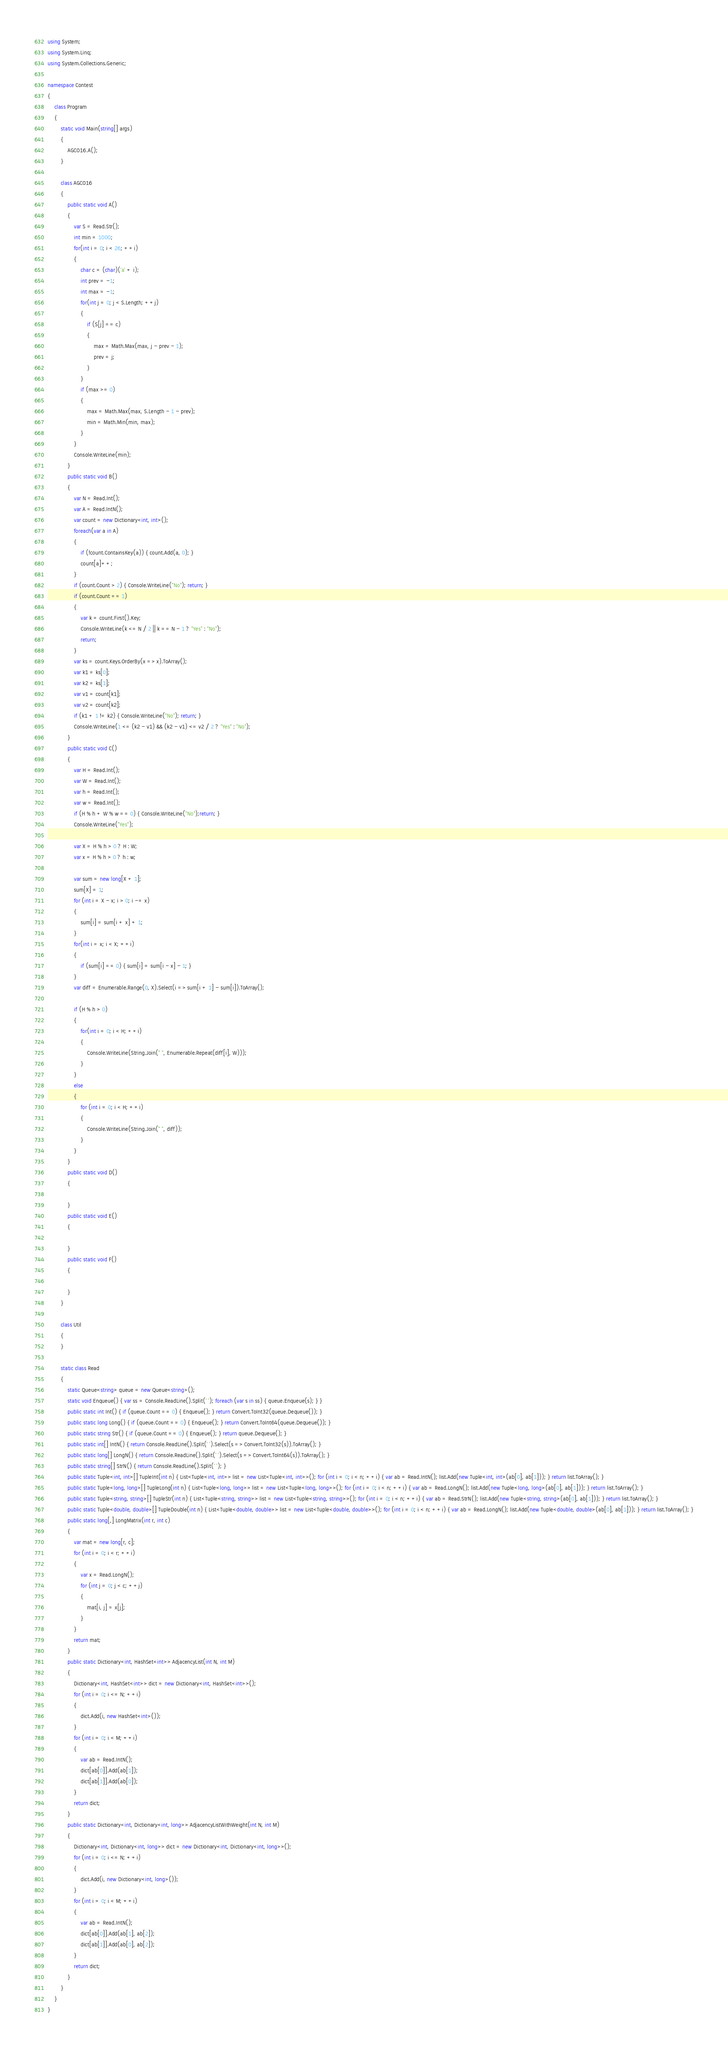Convert code to text. <code><loc_0><loc_0><loc_500><loc_500><_C#_>using System;
using System.Linq;
using System.Collections.Generic;

namespace Contest
{
    class Program
    {
        static void Main(string[] args)
        {
            AGC016.A();
        }

        class AGC016
        {
            public static void A()
            {
                var S = Read.Str();
                int min = 1000;
                for(int i = 0; i < 26; ++i)
                {
                    char c = (char)('a' + i);
                    int prev = -1;
                    int max = -1;
                    for(int j = 0; j < S.Length; ++j)
                    {
                        if (S[j] == c)
                        {
                            max = Math.Max(max, j - prev - 1);
                            prev = j;
                        }
                    }
                    if (max >= 0)
                    {
                        max = Math.Max(max, S.Length - 1 - prev);
                        min = Math.Min(min, max);
                    }
                }
                Console.WriteLine(min);
            }
            public static void B()
            {
                var N = Read.Int();
                var A = Read.IntN();
                var count = new Dictionary<int, int>();
                foreach(var a in A)
                {
                    if (!count.ContainsKey(a)) { count.Add(a, 0); }
                    count[a]++;
                }
                if (count.Count > 2) { Console.WriteLine("No"); return; }
                if (count.Count == 1)
                {
                    var k = count.First().Key;
                    Console.WriteLine(k <= N / 2 || k == N - 1 ? "Yes" : "No");
                    return;
                }
                var ks = count.Keys.OrderBy(x => x).ToArray();
                var k1 = ks[0];
                var k2 = ks[1];
                var v1 = count[k1];
                var v2 = count[k2];
                if (k1 + 1 != k2) { Console.WriteLine("No"); return; }
                Console.WriteLine(1 <= (k2 - v1) && (k2 - v1) <= v2 / 2 ? "Yes" : "No");
            }
            public static void C()
            {
                var H = Read.Int();
                var W = Read.Int();
                var h = Read.Int();
                var w = Read.Int();
                if (H % h + W % w == 0) { Console.WriteLine("No");return; }
                Console.WriteLine("Yes");

                var X = H % h > 0 ? H : W;
                var x = H % h > 0 ? h : w;

                var sum = new long[X + 1];
                sum[X] = 1;
                for (int i = X - x; i > 0; i -= x)
                {
                    sum[i] = sum[i + x] + 1;
                }
                for(int i = x; i < X; ++i)
                {
                    if (sum[i] == 0) { sum[i] = sum[i - x] - 1; }
                }
                var diff = Enumerable.Range(0, X).Select(i => sum[i + 1] - sum[i]).ToArray();

                if (H % h > 0)
                {
                    for(int i = 0; i < H; ++i)
                    {
                        Console.WriteLine(String.Join(" ", Enumerable.Repeat(diff[i], W)));
                    }
                }
                else
                {
                    for (int i = 0; i < H; ++i)
                    {
                        Console.WriteLine(String.Join(" ", diff));
                    }
                }
            }
            public static void D()
            {

            }
            public static void E()
            {

            }
            public static void F()
            {

            }
        }

        class Util
        {
        }

        static class Read
        {
            static Queue<string> queue = new Queue<string>();
            static void Enqueue() { var ss = Console.ReadLine().Split(' '); foreach (var s in ss) { queue.Enqueue(s); } }
            public static int Int() { if (queue.Count == 0) { Enqueue(); } return Convert.ToInt32(queue.Dequeue()); }
            public static long Long() { if (queue.Count == 0) { Enqueue(); } return Convert.ToInt64(queue.Dequeue()); }
            public static string Str() { if (queue.Count == 0) { Enqueue(); } return queue.Dequeue(); }
            public static int[] IntN() { return Console.ReadLine().Split(' ').Select(s => Convert.ToInt32(s)).ToArray(); }
            public static long[] LongN() { return Console.ReadLine().Split(' ').Select(s => Convert.ToInt64(s)).ToArray(); }
            public static string[] StrN() { return Console.ReadLine().Split(' '); }
            public static Tuple<int, int>[] TupleInt(int n) { List<Tuple<int, int>> list = new List<Tuple<int, int>>(); for (int i = 0; i < n; ++i) { var ab = Read.IntN(); list.Add(new Tuple<int, int>(ab[0], ab[1])); } return list.ToArray(); }
            public static Tuple<long, long>[] TupleLong(int n) { List<Tuple<long, long>> list = new List<Tuple<long, long>>(); for (int i = 0; i < n; ++i) { var ab = Read.LongN(); list.Add(new Tuple<long, long>(ab[0], ab[1])); } return list.ToArray(); }
            public static Tuple<string, string>[] TupleStr(int n) { List<Tuple<string, string>> list = new List<Tuple<string, string>>(); for (int i = 0; i < n; ++i) { var ab = Read.StrN(); list.Add(new Tuple<string, string>(ab[0], ab[1])); } return list.ToArray(); }
            public static Tuple<double, double>[] TupleDouble(int n) { List<Tuple<double, double>> list = new List<Tuple<double, double>>(); for (int i = 0; i < n; ++i) { var ab = Read.LongN(); list.Add(new Tuple<double, double>(ab[0], ab[1])); } return list.ToArray(); }
            public static long[,] LongMatrix(int r, int c)
            {
                var mat = new long[r, c];
                for (int i = 0; i < r; ++i)
                {
                    var x = Read.LongN();
                    for (int j = 0; j < c; ++j)
                    {
                        mat[i, j] = x[j];
                    }
                }
                return mat;
            }
            public static Dictionary<int, HashSet<int>> AdjacencyList(int N, int M)
            {
                Dictionary<int, HashSet<int>> dict = new Dictionary<int, HashSet<int>>();
                for (int i = 0; i <= N; ++i)
                {
                    dict.Add(i, new HashSet<int>());
                }
                for (int i = 0; i < M; ++i)
                {
                    var ab = Read.IntN();
                    dict[ab[0]].Add(ab[1]);
                    dict[ab[1]].Add(ab[0]);
                }
                return dict;
            }
            public static Dictionary<int, Dictionary<int, long>> AdjacencyListWithWeight(int N, int M)
            {
                Dictionary<int, Dictionary<int, long>> dict = new Dictionary<int, Dictionary<int, long>>();
                for (int i = 0; i <= N; ++i)
                {
                    dict.Add(i, new Dictionary<int, long>());
                }
                for (int i = 0; i < M; ++i)
                {
                    var ab = Read.IntN();
                    dict[ab[0]].Add(ab[1], ab[2]);
                    dict[ab[1]].Add(ab[0], ab[2]);
                }
                return dict;
            }
        }
    }
}
</code> 